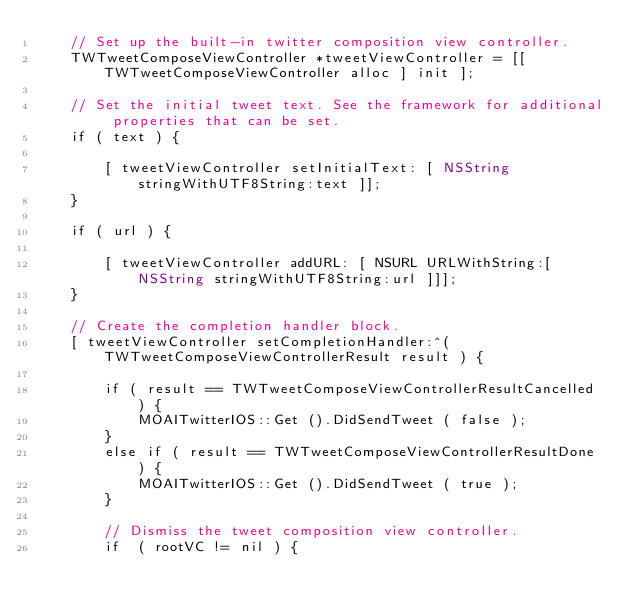Convert code to text. <code><loc_0><loc_0><loc_500><loc_500><_ObjectiveC_>	// Set up the built-in twitter composition view controller.
    TWTweetComposeViewController *tweetViewController = [[ TWTweetComposeViewController alloc ] init ];
    
    // Set the initial tweet text. See the framework for additional properties that can be set.
	if ( text ) {
		
		[ tweetViewController setInitialText: [ NSString stringWithUTF8String:text ]];
	}
	
	if ( url ) {
		
		[ tweetViewController addURL: [ NSURL URLWithString:[ NSString stringWithUTF8String:url ]]]; 
	}
    
    // Create the completion handler block.
    [ tweetViewController setCompletionHandler:^( TWTweetComposeViewControllerResult result ) {
				
		if ( result == TWTweetComposeViewControllerResultCancelled ) {
			MOAITwitterIOS::Get ().DidSendTweet ( false );
		}
		else if ( result == TWTweetComposeViewControllerResultDone ) {
			MOAITwitterIOS::Get ().DidSendTweet ( true );
		}
		
        // Dismiss the tweet composition view controller.
		if  ( rootVC != nil ) {</code> 